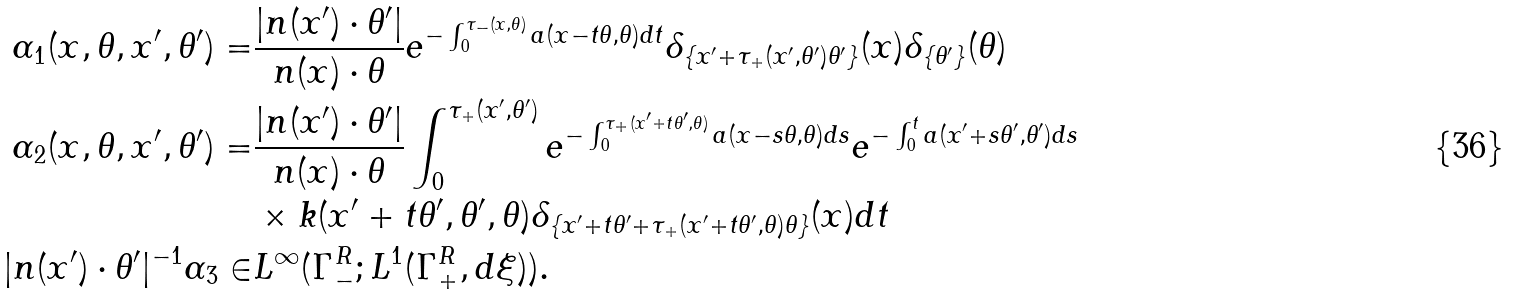Convert formula to latex. <formula><loc_0><loc_0><loc_500><loc_500>\alpha _ { 1 } ( x , \theta , x ^ { \prime } , \theta ^ { \prime } ) = & \frac { | n ( x ^ { \prime } ) \cdot \theta ^ { \prime } | } { n ( x ) \cdot \theta } e ^ { - \int _ { 0 } ^ { \tau _ { - } ( x , \theta ) } a ( x - t \theta , \theta ) d t } \delta _ { \{ x ^ { \prime } + \tau _ { + } ( x ^ { \prime } , \theta ^ { \prime } ) \theta ^ { \prime } \} } ( x ) \delta _ { \{ \theta ^ { \prime } \} } ( \theta ) \\ \alpha _ { 2 } ( x , \theta , x ^ { \prime } , \theta ^ { \prime } ) = & \frac { | n ( x ^ { \prime } ) \cdot \theta ^ { \prime } | } { n ( x ) \cdot \theta } \int _ { 0 } ^ { \tau _ { + } ( x ^ { \prime } , \theta ^ { \prime } ) } e ^ { - \int _ { 0 } ^ { \tau _ { + } ( x ^ { \prime } + t \theta ^ { \prime } , \theta ) } a ( x - s \theta , \theta ) d s } e ^ { - \int _ { 0 } ^ { t } a ( x ^ { \prime } + s \theta ^ { \prime } , \theta ^ { \prime } ) d s } \\ & \times k ( x ^ { \prime } + t \theta ^ { \prime } , \theta ^ { \prime } , \theta ) \delta _ { \{ x ^ { \prime } + t \theta ^ { \prime } + \tau _ { + } ( x ^ { \prime } + t \theta ^ { \prime } , \theta ) \theta \} } ( x ) d t \\ | n ( x ^ { \prime } ) \cdot \theta ^ { \prime } | ^ { - 1 } \alpha _ { 3 } \in & L ^ { \infty } ( \Gamma ^ { R } _ { - } ; L ^ { 1 } ( \Gamma ^ { R } _ { + } , d \xi ) ) .</formula> 